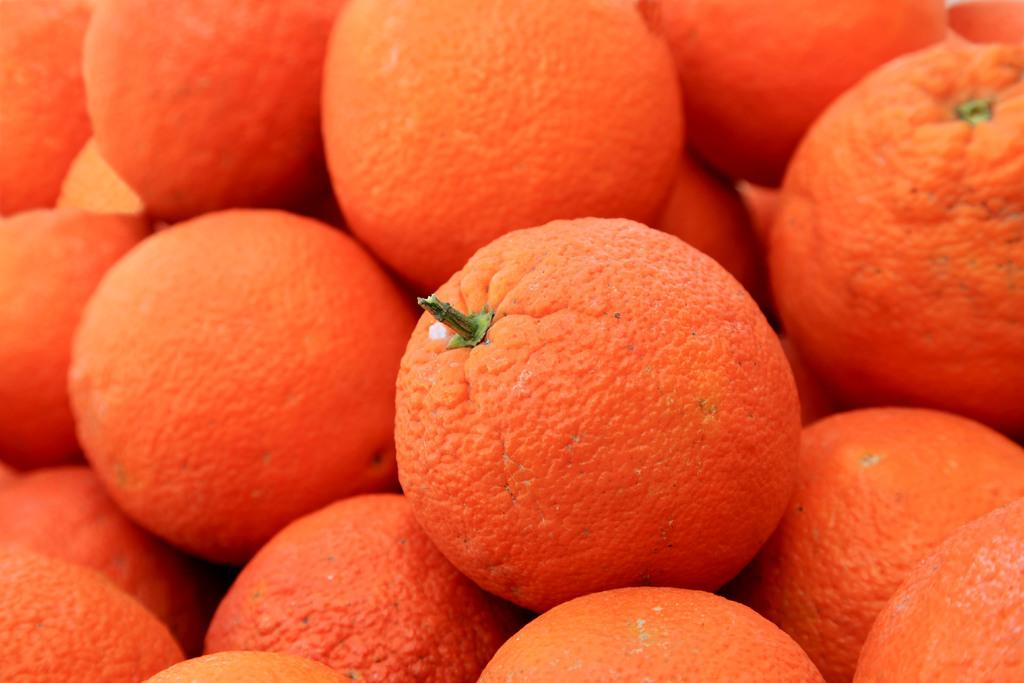What type of fruit is present in the image? There are oranges in the image. Can you tell me how many donkeys are visible in the image? There are no donkeys present in the image; it only features oranges. What type of beggar can be seen interacting with the oranges in the image? There is no beggar present in the image; only oranges are visible. 